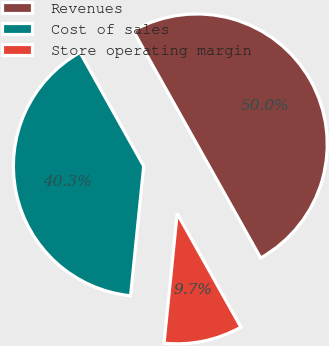Convert chart to OTSL. <chart><loc_0><loc_0><loc_500><loc_500><pie_chart><fcel>Revenues<fcel>Cost of sales<fcel>Store operating margin<nl><fcel>50.0%<fcel>40.26%<fcel>9.74%<nl></chart> 